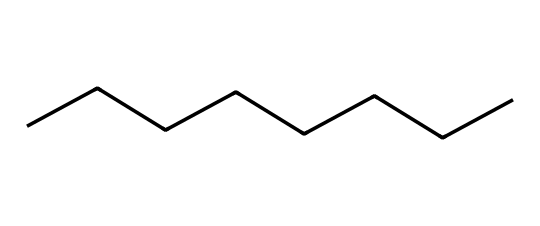What is the total number of carbon atoms in octane? The SMILES representation indicates a linear chain of carbon atoms. Counting the "C" in "CCCCCCCC," we find there are 8 carbon atoms in total.
Answer: 8 How many hydrogen atoms are present in octane? For aliphatic compounds, the general formula is CnH2n+2. By substituting n with 8 (the number of carbon atoms), we calculate 2(8)+2, which equals 18 hydrogen atoms.
Answer: 18 What type of hydrocarbon is octane classified as? Octane consists solely of carbon and hydrogen atoms arranged in a non-aromatic structure. Therefore, it is classified as an aliphatic hydrocarbon.
Answer: aliphatic How many single bonds are in the octane structure? In the given linear structure derived from the SMILES representation, there are 7 single bonds connecting the 8 carbon atoms (each adjacent pair of carbons has a single bond).
Answer: 7 What is the molecular formula for octane? By taking into account the number of carbon and hydrogen atoms derived from the previous answers, the molecular formula calculates to C8H18.
Answer: C8H18 Why is octane considered a key component of gasoline? Octane has a high energy content and a suitable boiling point, making it an efficient fuel for combustion engines; it helps prevent engine knocking.
Answer: high energy content 